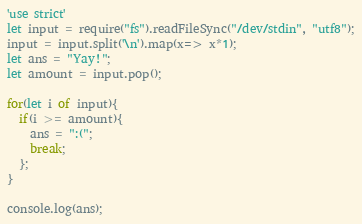Convert code to text. <code><loc_0><loc_0><loc_500><loc_500><_JavaScript_>'use strict'
let input = require("fs").readFileSync("/dev/stdin", "utf8");
input = input.split('\n').map(x=> x*1);
let ans = "Yay!";
let amount = input.pop();

for(let i of input){
  if(i >= amount){
  	ans = ":(";
    break;
  };
}

console.log(ans);
</code> 